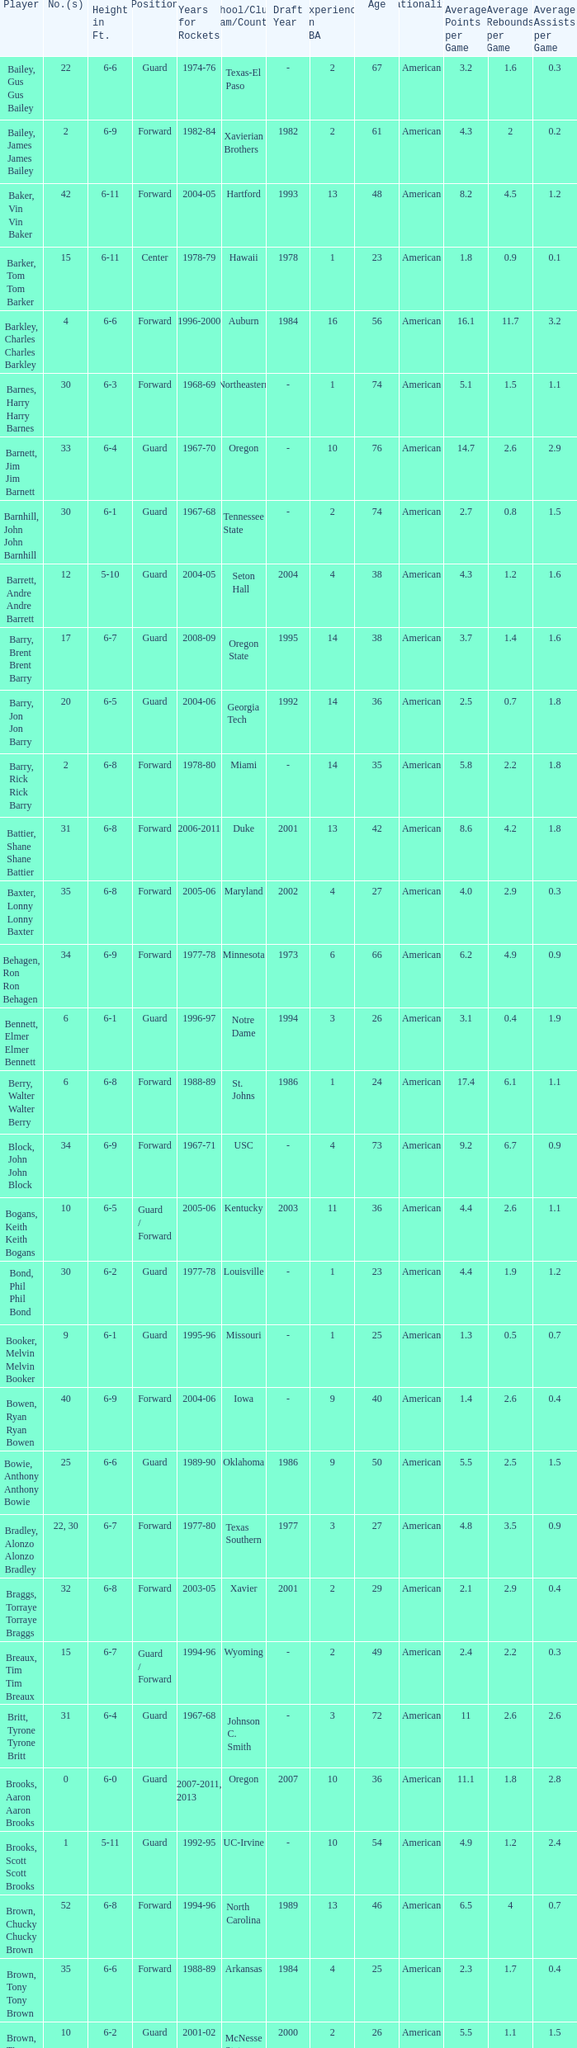What years did the player from LaSalle play for the Rockets? 1982-83. 